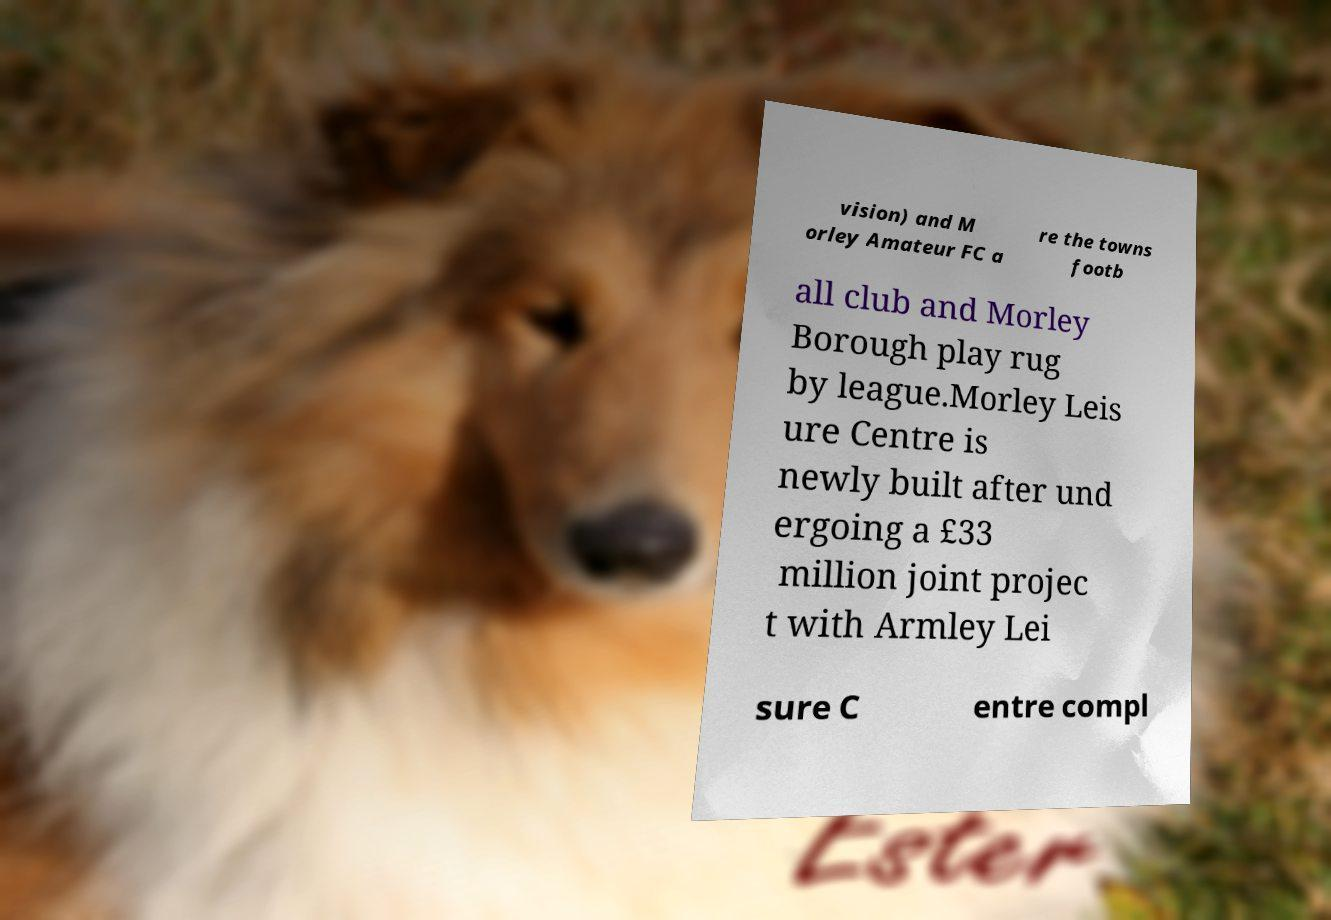Please identify and transcribe the text found in this image. vision) and M orley Amateur FC a re the towns footb all club and Morley Borough play rug by league.Morley Leis ure Centre is newly built after und ergoing a £33 million joint projec t with Armley Lei sure C entre compl 